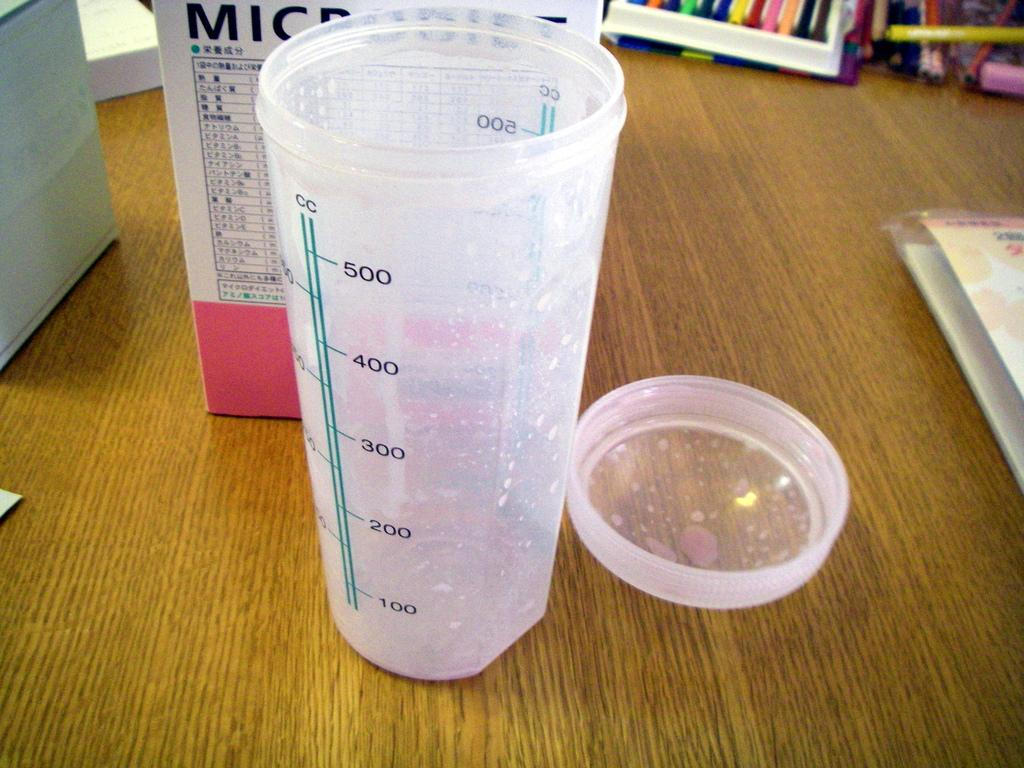<image>
Summarize the visual content of the image. A plastic cup is able to measure up to 500 cc. 